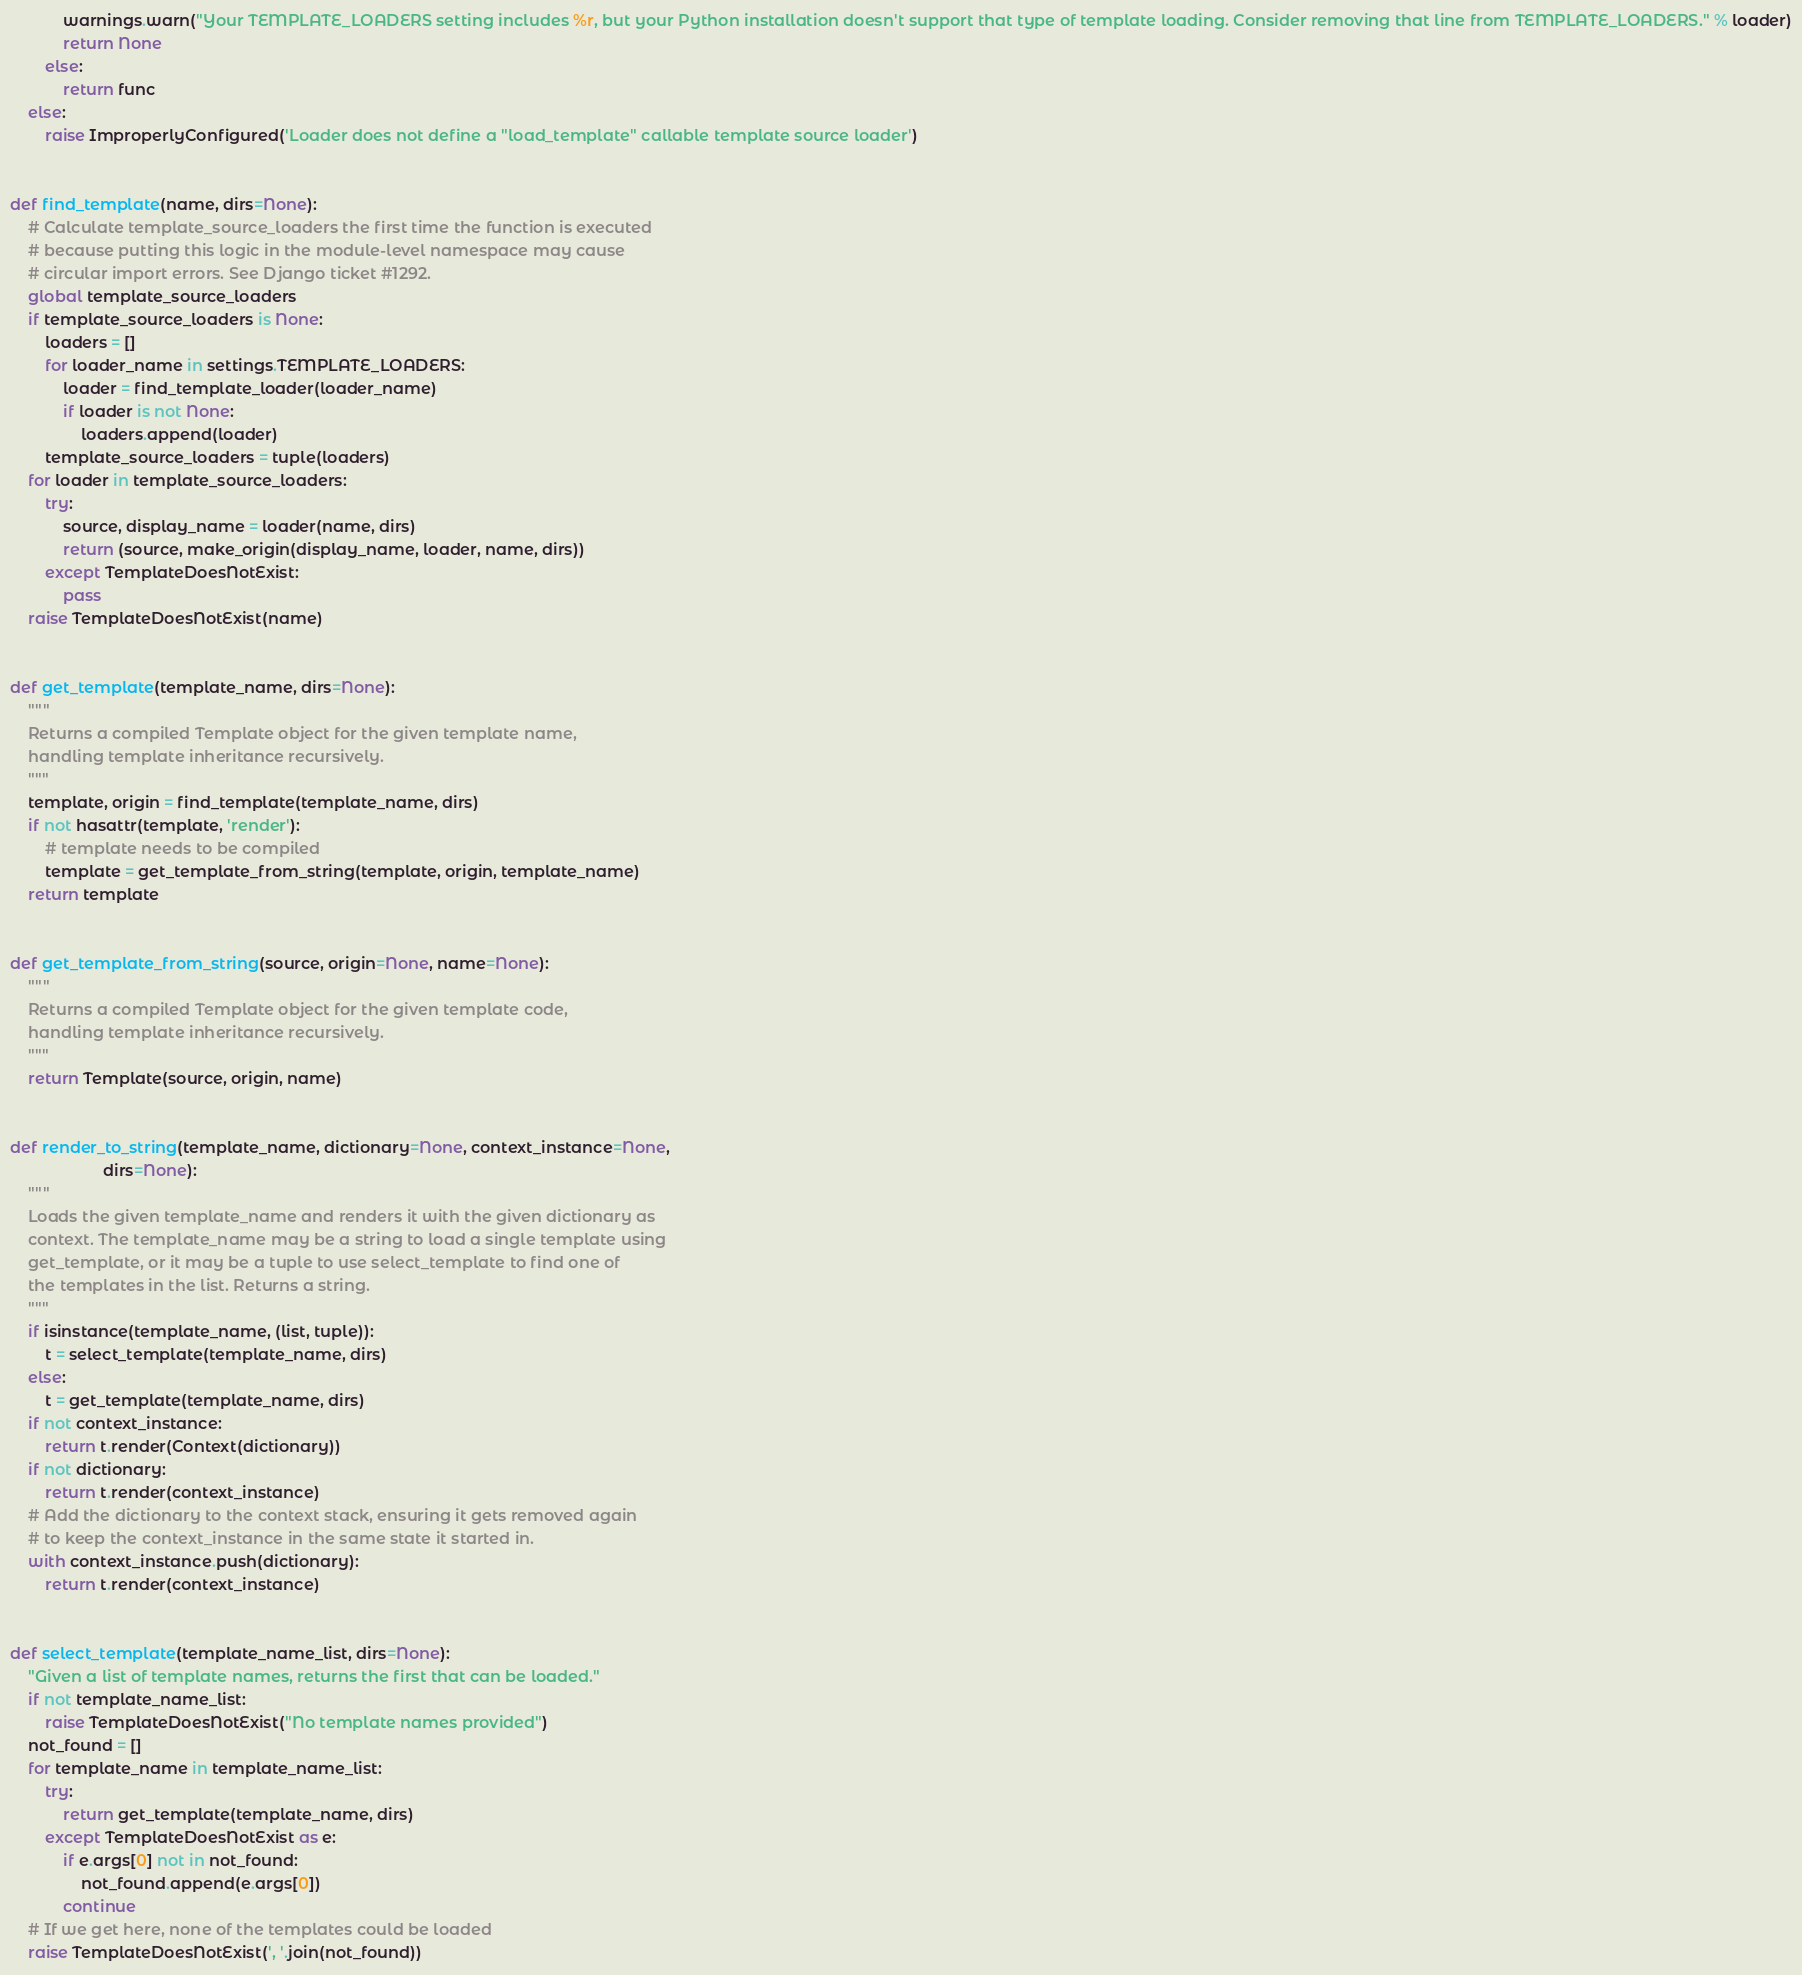Convert code to text. <code><loc_0><loc_0><loc_500><loc_500><_Python_>            warnings.warn("Your TEMPLATE_LOADERS setting includes %r, but your Python installation doesn't support that type of template loading. Consider removing that line from TEMPLATE_LOADERS." % loader)
            return None
        else:
            return func
    else:
        raise ImproperlyConfigured('Loader does not define a "load_template" callable template source loader')


def find_template(name, dirs=None):
    # Calculate template_source_loaders the first time the function is executed
    # because putting this logic in the module-level namespace may cause
    # circular import errors. See Django ticket #1292.
    global template_source_loaders
    if template_source_loaders is None:
        loaders = []
        for loader_name in settings.TEMPLATE_LOADERS:
            loader = find_template_loader(loader_name)
            if loader is not None:
                loaders.append(loader)
        template_source_loaders = tuple(loaders)
    for loader in template_source_loaders:
        try:
            source, display_name = loader(name, dirs)
            return (source, make_origin(display_name, loader, name, dirs))
        except TemplateDoesNotExist:
            pass
    raise TemplateDoesNotExist(name)


def get_template(template_name, dirs=None):
    """
    Returns a compiled Template object for the given template name,
    handling template inheritance recursively.
    """
    template, origin = find_template(template_name, dirs)
    if not hasattr(template, 'render'):
        # template needs to be compiled
        template = get_template_from_string(template, origin, template_name)
    return template


def get_template_from_string(source, origin=None, name=None):
    """
    Returns a compiled Template object for the given template code,
    handling template inheritance recursively.
    """
    return Template(source, origin, name)


def render_to_string(template_name, dictionary=None, context_instance=None,
                     dirs=None):
    """
    Loads the given template_name and renders it with the given dictionary as
    context. The template_name may be a string to load a single template using
    get_template, or it may be a tuple to use select_template to find one of
    the templates in the list. Returns a string.
    """
    if isinstance(template_name, (list, tuple)):
        t = select_template(template_name, dirs)
    else:
        t = get_template(template_name, dirs)
    if not context_instance:
        return t.render(Context(dictionary))
    if not dictionary:
        return t.render(context_instance)
    # Add the dictionary to the context stack, ensuring it gets removed again
    # to keep the context_instance in the same state it started in.
    with context_instance.push(dictionary):
        return t.render(context_instance)


def select_template(template_name_list, dirs=None):
    "Given a list of template names, returns the first that can be loaded."
    if not template_name_list:
        raise TemplateDoesNotExist("No template names provided")
    not_found = []
    for template_name in template_name_list:
        try:
            return get_template(template_name, dirs)
        except TemplateDoesNotExist as e:
            if e.args[0] not in not_found:
                not_found.append(e.args[0])
            continue
    # If we get here, none of the templates could be loaded
    raise TemplateDoesNotExist(', '.join(not_found))
</code> 